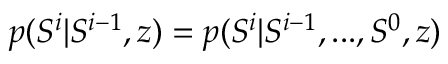<formula> <loc_0><loc_0><loc_500><loc_500>p ( S ^ { i } | S ^ { i - 1 } , z ) = p ( S ^ { i } | S ^ { i - 1 } , \dots , S ^ { 0 } , z )</formula> 